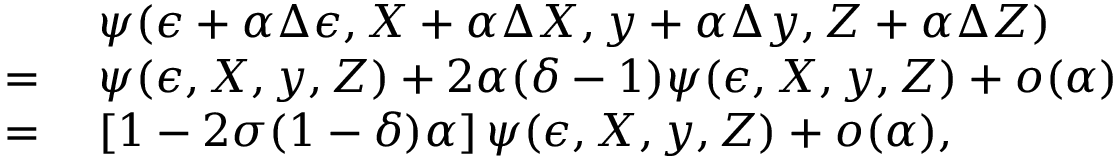<formula> <loc_0><loc_0><loc_500><loc_500>\begin{array} { r l } & { \, \psi ( \epsilon + \alpha \Delta \epsilon , X + \alpha \Delta X , y + \alpha \Delta y , Z + \alpha \Delta Z ) } \\ { = } & { \, \psi ( \epsilon , X , y , Z ) + 2 \alpha ( \delta - 1 ) \psi ( \epsilon , X , y , Z ) + o ( \alpha ) } \\ { = } & { \, \left [ 1 - 2 \sigma ( 1 - \delta ) \alpha \right ] \psi ( \epsilon , X , y , Z ) + o ( \alpha ) , } \end{array}</formula> 